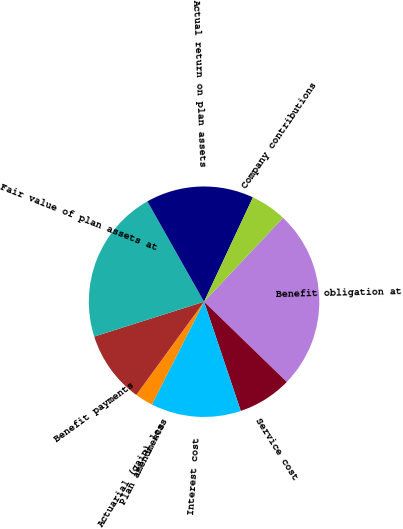Convert chart to OTSL. <chart><loc_0><loc_0><loc_500><loc_500><pie_chart><fcel>Benefit obligation at<fcel>Service cost<fcel>Interest cost<fcel>Plan amendments<fcel>Actuarial (gain) loss<fcel>Benefit payments<fcel>Fair value of plan assets at<fcel>Actual return on plan assets<fcel>Company contributions<nl><fcel>25.24%<fcel>7.58%<fcel>12.63%<fcel>0.01%<fcel>2.53%<fcel>10.1%<fcel>21.71%<fcel>15.15%<fcel>5.05%<nl></chart> 